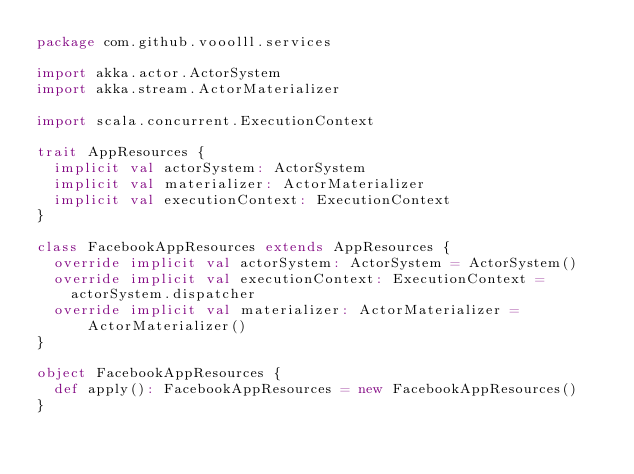<code> <loc_0><loc_0><loc_500><loc_500><_Scala_>package com.github.vooolll.services

import akka.actor.ActorSystem
import akka.stream.ActorMaterializer

import scala.concurrent.ExecutionContext

trait AppResources {
  implicit val actorSystem: ActorSystem
  implicit val materializer: ActorMaterializer
  implicit val executionContext: ExecutionContext
}

class FacebookAppResources extends AppResources {
  override implicit val actorSystem: ActorSystem = ActorSystem()
  override implicit val executionContext: ExecutionContext =
    actorSystem.dispatcher
  override implicit val materializer: ActorMaterializer = ActorMaterializer()
}

object FacebookAppResources {
  def apply(): FacebookAppResources = new FacebookAppResources()
}
</code> 